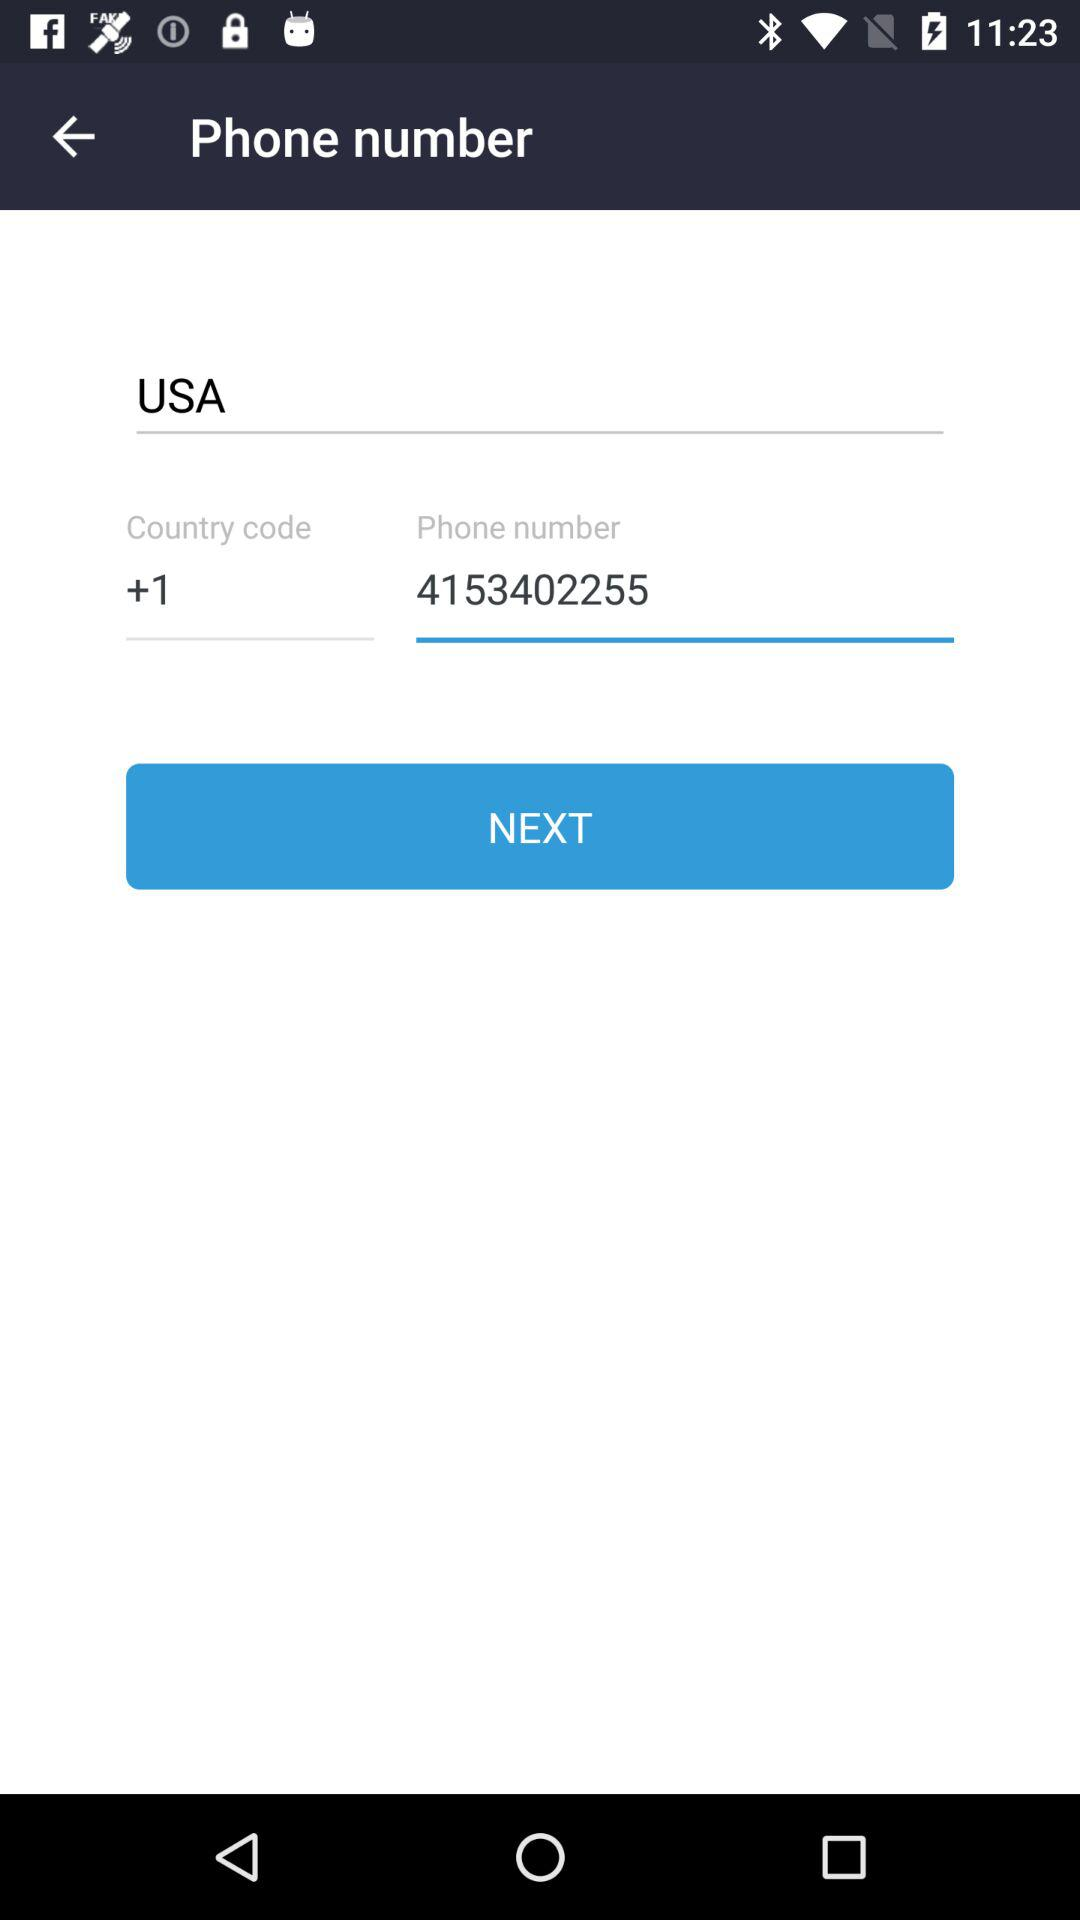What is the country name? The country name is the USA. 